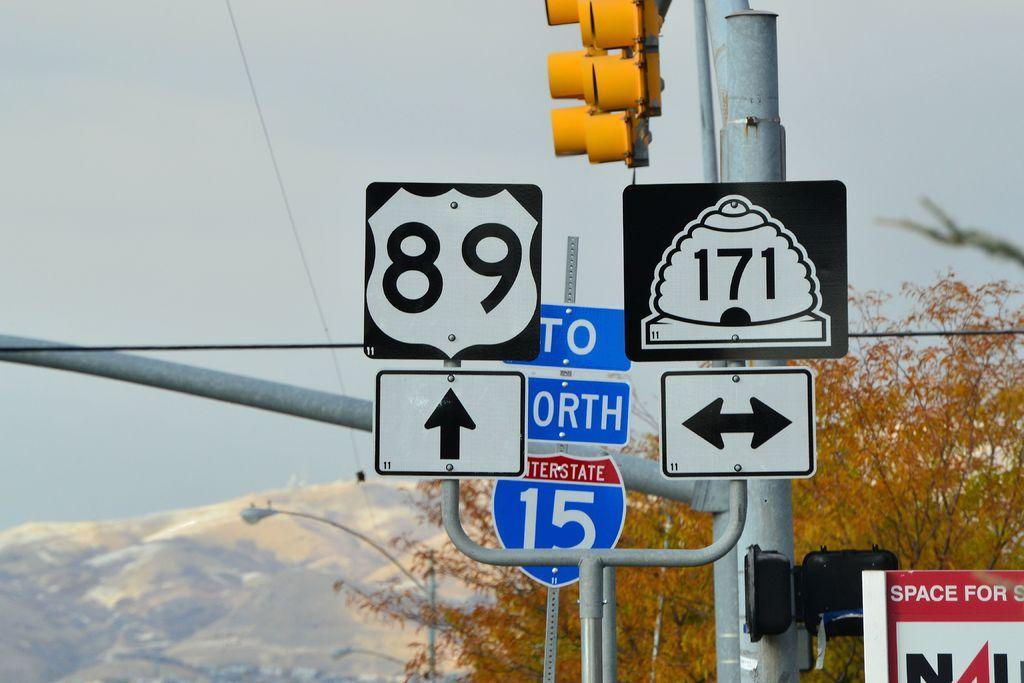Provide a one-sentence caption for the provided image. Road signs that read 89 and 171 sit on a traffic light. 